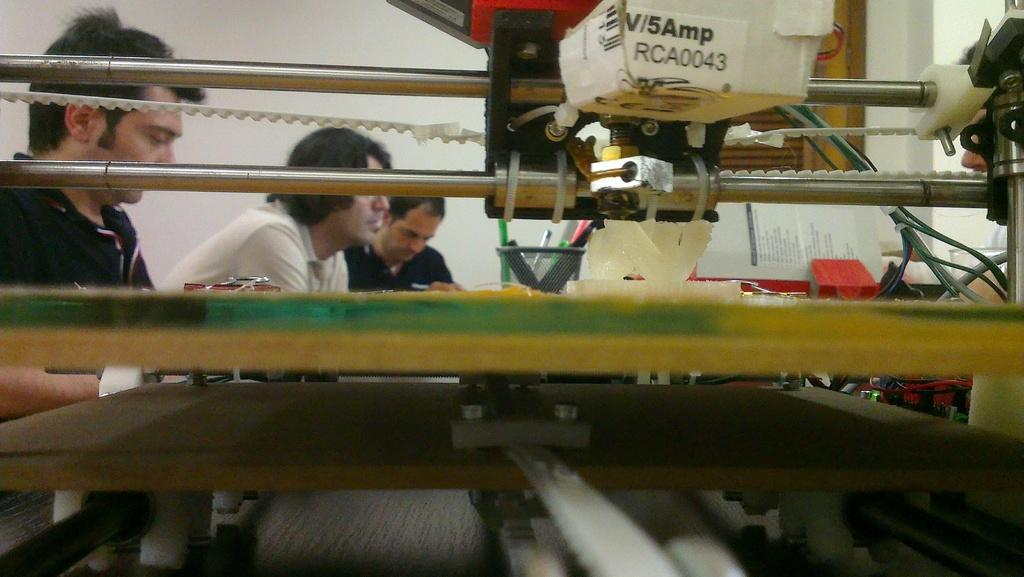How many people are present in the image? There are three persons in the image. What else can be seen in the image besides the people? There are machines and papers visible in the image. What is visible in the background of the image? There is a wall in the background of the image. What type of drug is being administered to the persons in the image? There is no indication of any drug being administered or present in the image. 